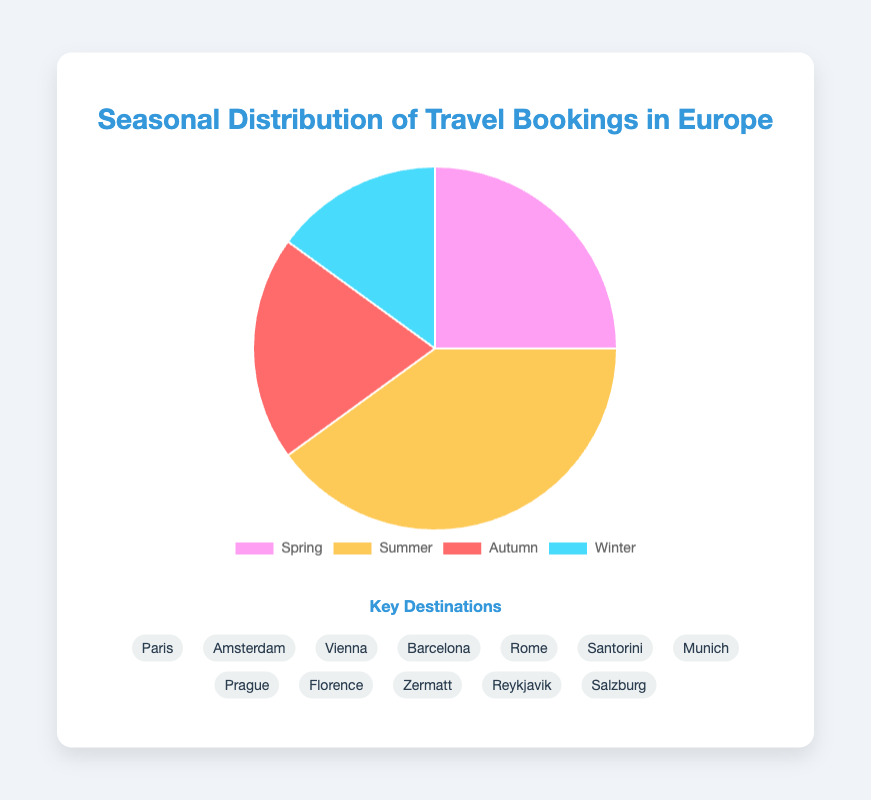Which season has the highest percentage of travel bookings? By looking at the pie chart, identify the largest slice, which corresponds to the highest percentage. The summer season slice is larger than the others at 40%.
Answer: Summer Which season accounts for 15% of the travel bookings? Find the slice labeled with "15%". The winter season matches this percentage.
Answer: Winter What is the total percentage of travel bookings in Spring and Autumn combined? Add the percentages of Spring (25%) and Autumn (20%). 25 + 20 = 45%.
Answer: 45% Which season has more bookings, Spring or Autumn? Compare the percentages of Spring (25%) and Autumn (20%). 25% is greater than 20%.
Answer: Spring What are the key destinations for the season with the lowest percentage of travel bookings? Identify the season with the lowest percentage (Winter at 15%) and list its key destinations: Zermatt, Reykjavik, and Salzburg.
Answer: Zermatt, Reykjavik, and Salzburg How much greater is the percentage of travel bookings in Summer compared to Winter? Subtract Winter's percentage (15%) from Summer's percentage (40%). 40 - 15 = 25%.
Answer: 25% What’s the average percentage of travel bookings across all seasons? Sum the percentages for all seasons and then divide by the number of seasons: (25+40+20+15) / 4 = 25%.
Answer: 25% What is the difference in percentage between the seasons with the highest and lowest bookings? Subtract the percentage of the lowest season (Winter at 15%) from the percentage of the highest season (Summer at 40%). 40 - 15 = 25%.
Answer: 25% Which color represents the Autumn season in the pie chart? Identify the color used for the Autumn slice by visually matching it to the legend. In the given data, Autumn is represented by a red slice.
Answer: Red 